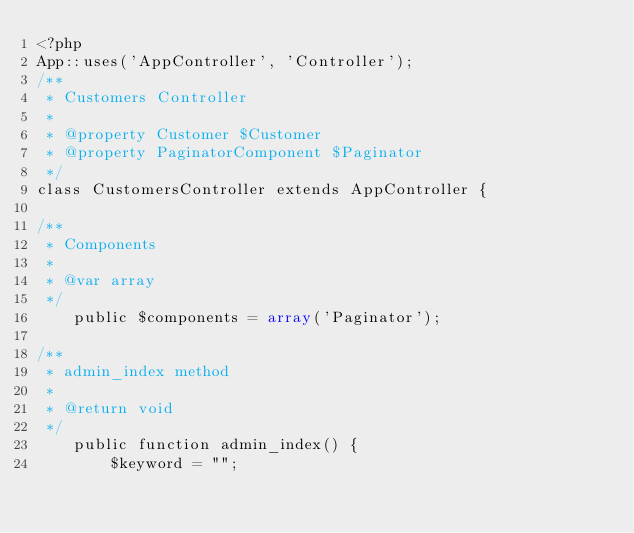Convert code to text. <code><loc_0><loc_0><loc_500><loc_500><_PHP_><?php
App::uses('AppController', 'Controller');
/**
 * Customers Controller
 *
 * @property Customer $Customer
 * @property PaginatorComponent $Paginator
 */
class CustomersController extends AppController {

/**
 * Components
 *
 * @var array
 */
	public $components = array('Paginator');

/**
 * admin_index method
 *
 * @return void
 */
	public function admin_index() {
        $keyword = "";</code> 